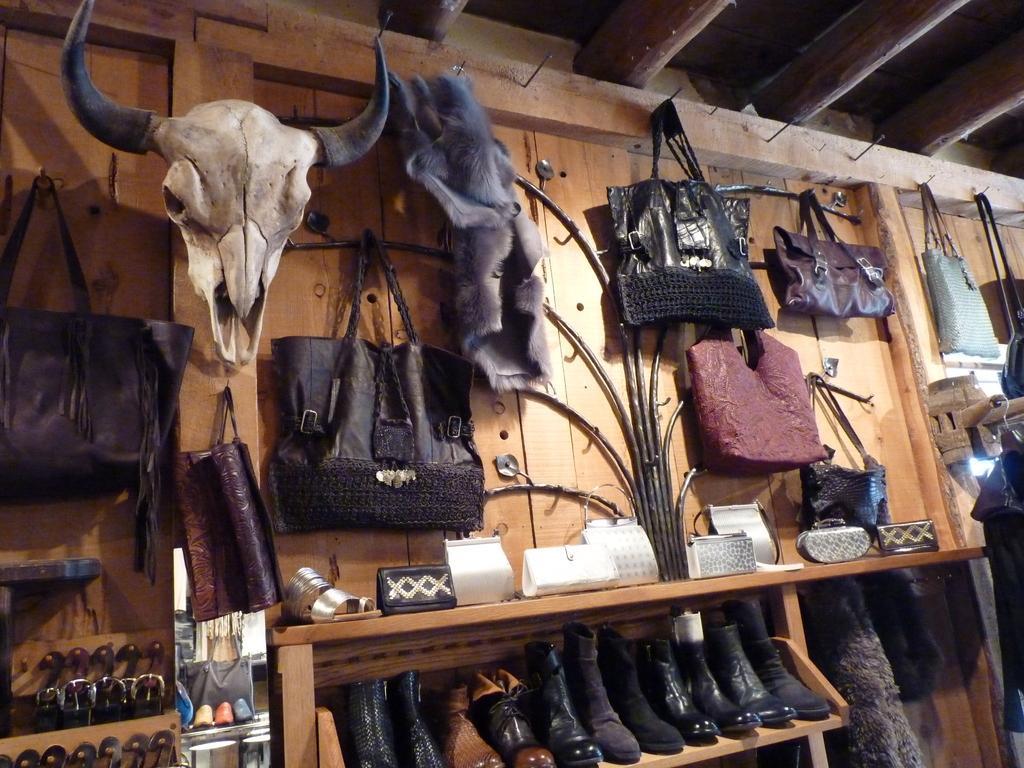Describe this image in one or two sentences. In the given image we can see that, this is a store. This are the shoes, handbag, purse. 